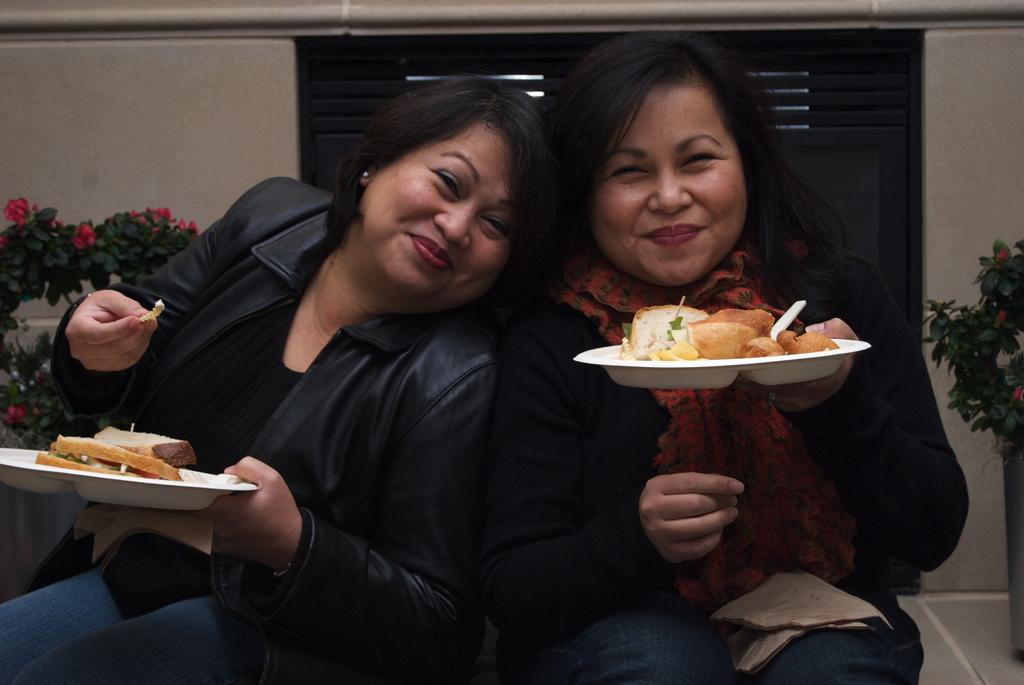How would you summarize this image in a sentence or two? In this picture I cans see 2 women sitting in front and I see that they're smiling and they're holding plates and I can see food which is of white and brown color. In the background I can see the wall and I can also see few plants on which there are flowers. 